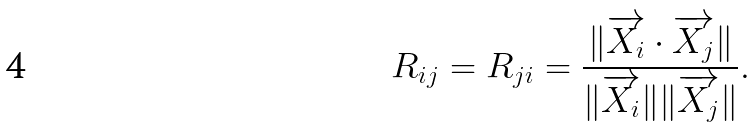<formula> <loc_0><loc_0><loc_500><loc_500>R _ { i j } = { R _ { j i } } = \frac { \| \overrightarrow { X _ { i } } \cdot \overrightarrow { X _ { j } } \| } { \| \overrightarrow { X _ { i } } \| \| \overrightarrow { X _ { j } } \| } .</formula> 